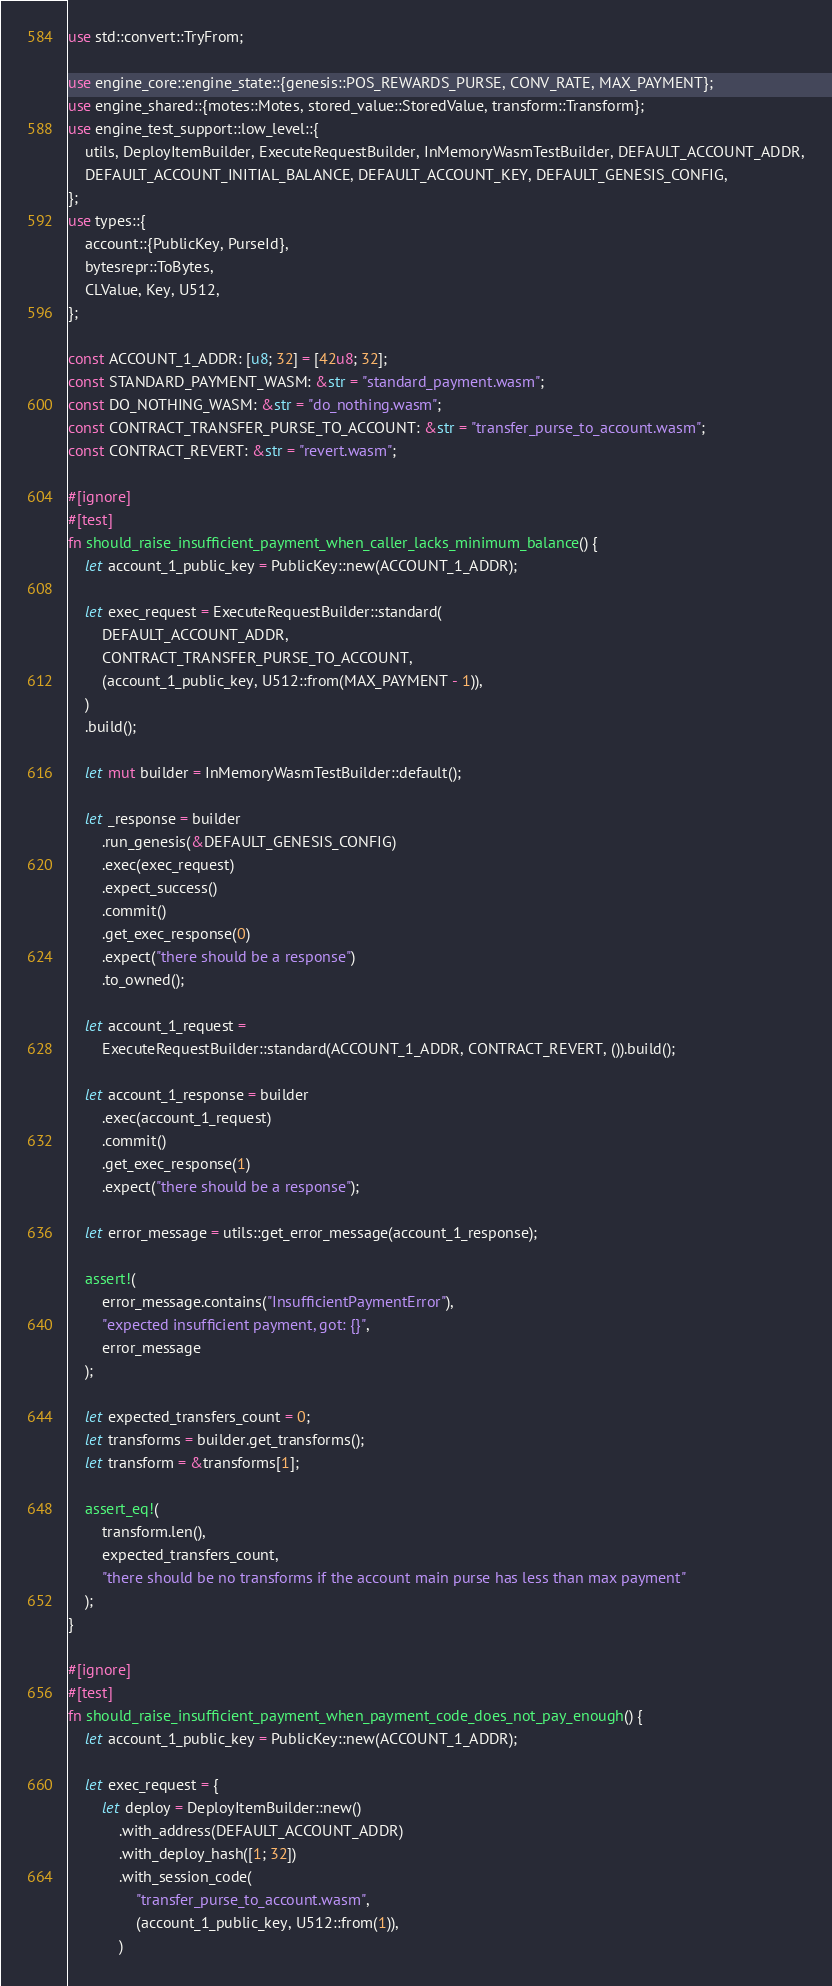Convert code to text. <code><loc_0><loc_0><loc_500><loc_500><_Rust_>use std::convert::TryFrom;

use engine_core::engine_state::{genesis::POS_REWARDS_PURSE, CONV_RATE, MAX_PAYMENT};
use engine_shared::{motes::Motes, stored_value::StoredValue, transform::Transform};
use engine_test_support::low_level::{
    utils, DeployItemBuilder, ExecuteRequestBuilder, InMemoryWasmTestBuilder, DEFAULT_ACCOUNT_ADDR,
    DEFAULT_ACCOUNT_INITIAL_BALANCE, DEFAULT_ACCOUNT_KEY, DEFAULT_GENESIS_CONFIG,
};
use types::{
    account::{PublicKey, PurseId},
    bytesrepr::ToBytes,
    CLValue, Key, U512,
};

const ACCOUNT_1_ADDR: [u8; 32] = [42u8; 32];
const STANDARD_PAYMENT_WASM: &str = "standard_payment.wasm";
const DO_NOTHING_WASM: &str = "do_nothing.wasm";
const CONTRACT_TRANSFER_PURSE_TO_ACCOUNT: &str = "transfer_purse_to_account.wasm";
const CONTRACT_REVERT: &str = "revert.wasm";

#[ignore]
#[test]
fn should_raise_insufficient_payment_when_caller_lacks_minimum_balance() {
    let account_1_public_key = PublicKey::new(ACCOUNT_1_ADDR);

    let exec_request = ExecuteRequestBuilder::standard(
        DEFAULT_ACCOUNT_ADDR,
        CONTRACT_TRANSFER_PURSE_TO_ACCOUNT,
        (account_1_public_key, U512::from(MAX_PAYMENT - 1)),
    )
    .build();

    let mut builder = InMemoryWasmTestBuilder::default();

    let _response = builder
        .run_genesis(&DEFAULT_GENESIS_CONFIG)
        .exec(exec_request)
        .expect_success()
        .commit()
        .get_exec_response(0)
        .expect("there should be a response")
        .to_owned();

    let account_1_request =
        ExecuteRequestBuilder::standard(ACCOUNT_1_ADDR, CONTRACT_REVERT, ()).build();

    let account_1_response = builder
        .exec(account_1_request)
        .commit()
        .get_exec_response(1)
        .expect("there should be a response");

    let error_message = utils::get_error_message(account_1_response);

    assert!(
        error_message.contains("InsufficientPaymentError"),
        "expected insufficient payment, got: {}",
        error_message
    );

    let expected_transfers_count = 0;
    let transforms = builder.get_transforms();
    let transform = &transforms[1];

    assert_eq!(
        transform.len(),
        expected_transfers_count,
        "there should be no transforms if the account main purse has less than max payment"
    );
}

#[ignore]
#[test]
fn should_raise_insufficient_payment_when_payment_code_does_not_pay_enough() {
    let account_1_public_key = PublicKey::new(ACCOUNT_1_ADDR);

    let exec_request = {
        let deploy = DeployItemBuilder::new()
            .with_address(DEFAULT_ACCOUNT_ADDR)
            .with_deploy_hash([1; 32])
            .with_session_code(
                "transfer_purse_to_account.wasm",
                (account_1_public_key, U512::from(1)),
            )</code> 